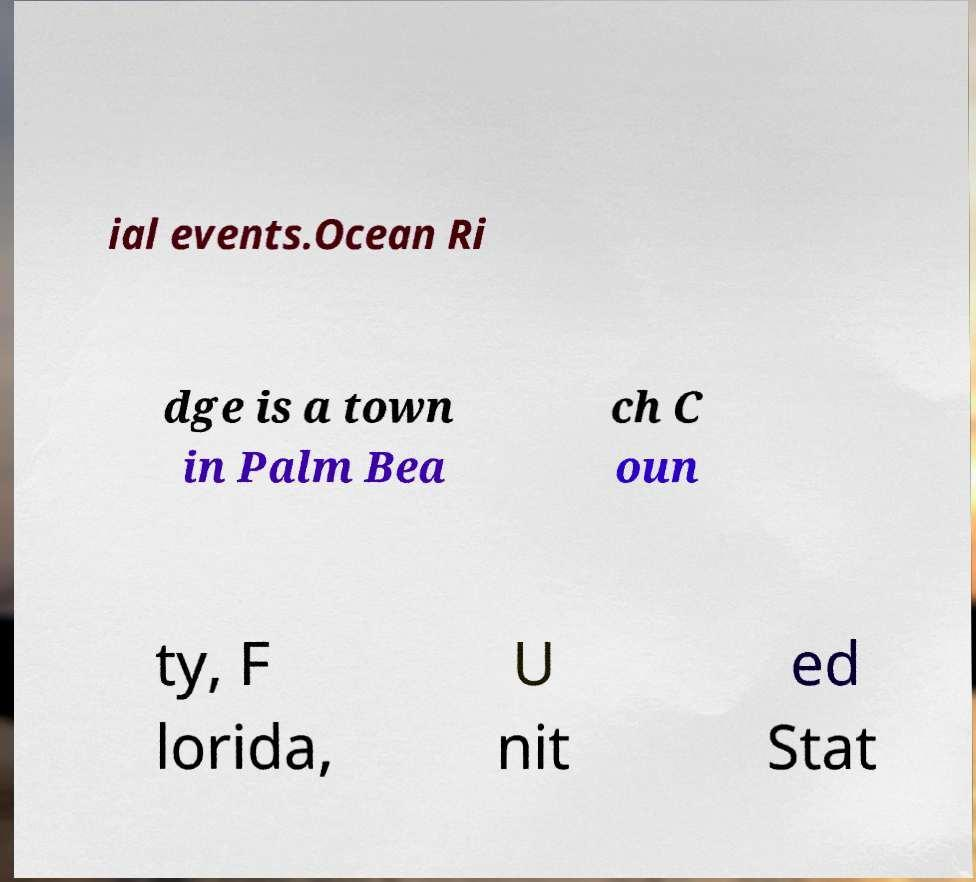I need the written content from this picture converted into text. Can you do that? ial events.Ocean Ri dge is a town in Palm Bea ch C oun ty, F lorida, U nit ed Stat 